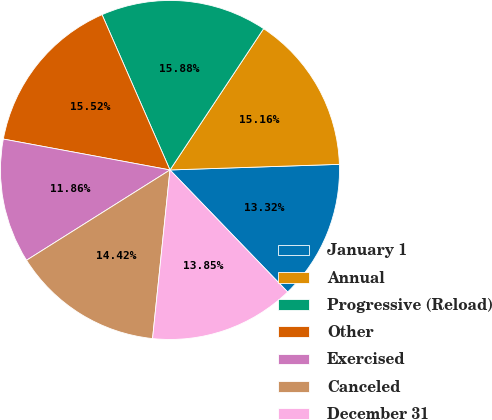<chart> <loc_0><loc_0><loc_500><loc_500><pie_chart><fcel>January 1<fcel>Annual<fcel>Progressive (Reload)<fcel>Other<fcel>Exercised<fcel>Canceled<fcel>December 31<nl><fcel>13.32%<fcel>15.16%<fcel>15.88%<fcel>15.52%<fcel>11.86%<fcel>14.42%<fcel>13.85%<nl></chart> 